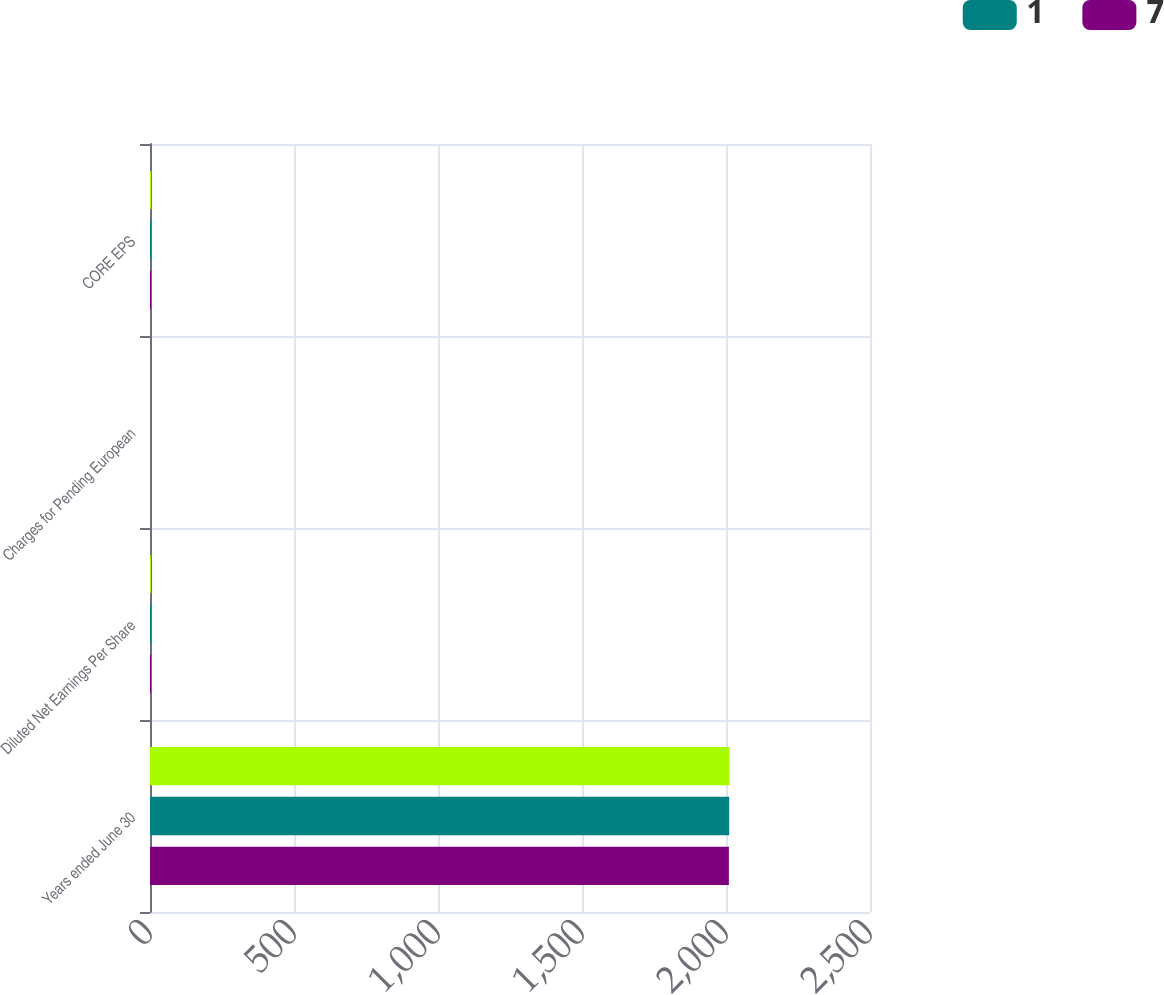Convert chart to OTSL. <chart><loc_0><loc_0><loc_500><loc_500><stacked_bar_chart><ecel><fcel>Years ended June 30<fcel>Diluted Net Earnings Per Share<fcel>Charges for Pending European<fcel>CORE EPS<nl><fcel>nan<fcel>2012<fcel>3.12<fcel>0.03<fcel>3.85<nl><fcel>1<fcel>2011<fcel>3.85<fcel>0.1<fcel>3.87<nl><fcel>7<fcel>2010<fcel>3.47<fcel>0.09<fcel>3.61<nl></chart> 